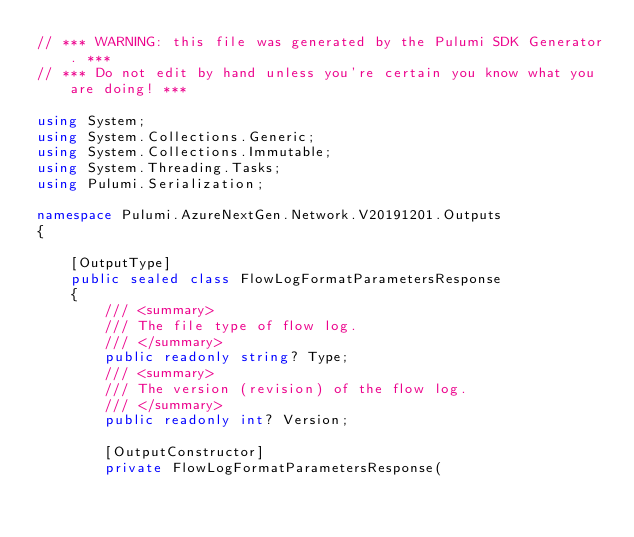Convert code to text. <code><loc_0><loc_0><loc_500><loc_500><_C#_>// *** WARNING: this file was generated by the Pulumi SDK Generator. ***
// *** Do not edit by hand unless you're certain you know what you are doing! ***

using System;
using System.Collections.Generic;
using System.Collections.Immutable;
using System.Threading.Tasks;
using Pulumi.Serialization;

namespace Pulumi.AzureNextGen.Network.V20191201.Outputs
{

    [OutputType]
    public sealed class FlowLogFormatParametersResponse
    {
        /// <summary>
        /// The file type of flow log.
        /// </summary>
        public readonly string? Type;
        /// <summary>
        /// The version (revision) of the flow log.
        /// </summary>
        public readonly int? Version;

        [OutputConstructor]
        private FlowLogFormatParametersResponse(</code> 